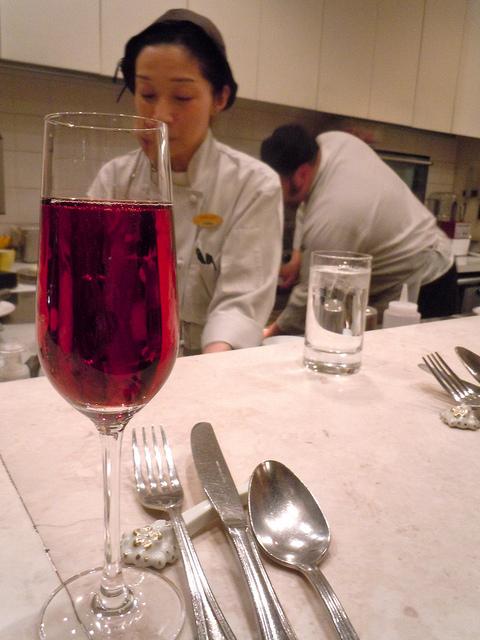What is in the glass closest to the lady?
Quick response, please. Water. What room is this?
Write a very short answer. Kitchen. What is on the table?
Quick response, please. Wine. How many glasses of wine are there?
Quick response, please. 1. Is the wine good?
Quick response, please. Yes. Could this be a wine tasting?
Be succinct. No. How many glasses are there?
Concise answer only. 2. How much wine is in the glasses?
Quick response, please. Lot. What do you think they're drinking?
Quick response, please. Wine. What liquid is in the vase?
Be succinct. Wine. 